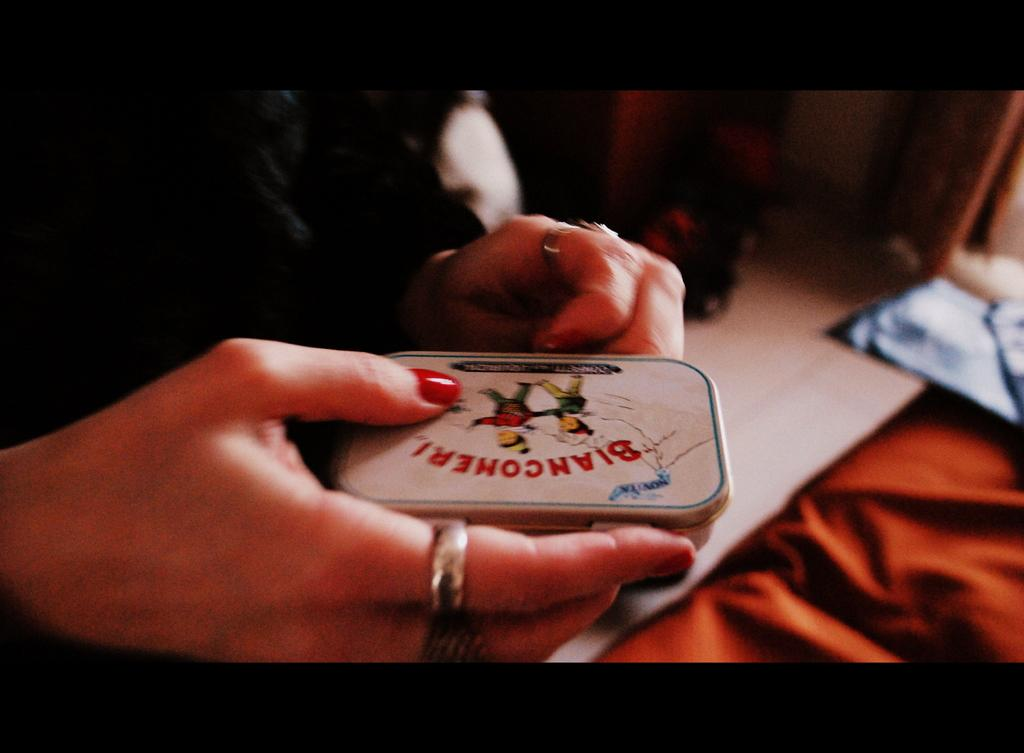Who is the main subject in the image? There is a woman in the image. What is the woman holding? The woman is holding a small box. What color is the cloth at the bottom of the image? The cloth at the bottom of the image is red. What is the woman wearing in the image? The woman is wearing a black dress. What type of discussion is taking place in the image? There is no discussion taking place in the image; it only shows a woman holding a small box and standing on a red cloth. 